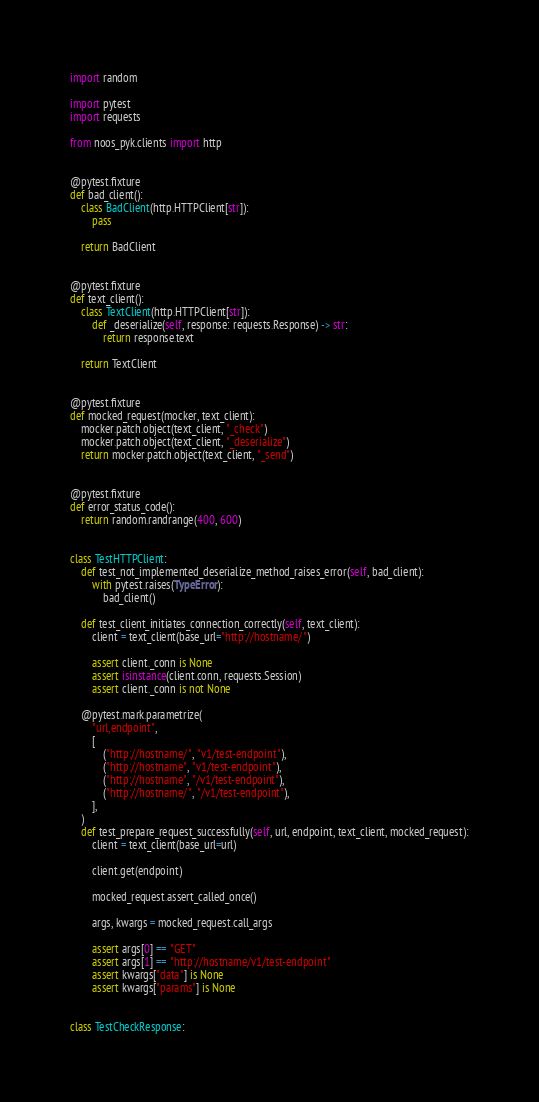Convert code to text. <code><loc_0><loc_0><loc_500><loc_500><_Python_>import random

import pytest
import requests

from noos_pyk.clients import http


@pytest.fixture
def bad_client():
    class BadClient(http.HTTPClient[str]):
        pass

    return BadClient


@pytest.fixture
def text_client():
    class TextClient(http.HTTPClient[str]):
        def _deserialize(self, response: requests.Response) -> str:
            return response.text

    return TextClient


@pytest.fixture
def mocked_request(mocker, text_client):
    mocker.patch.object(text_client, "_check")
    mocker.patch.object(text_client, "_deserialize")
    return mocker.patch.object(text_client, "_send")


@pytest.fixture
def error_status_code():
    return random.randrange(400, 600)


class TestHTTPClient:
    def test_not_implemented_deserialize_method_raises_error(self, bad_client):
        with pytest.raises(TypeError):
            bad_client()

    def test_client_initiates_connection_correctly(self, text_client):
        client = text_client(base_url="http://hostname/")

        assert client._conn is None
        assert isinstance(client.conn, requests.Session)
        assert client._conn is not None

    @pytest.mark.parametrize(
        "url,endpoint",
        [
            ("http://hostname/", "v1/test-endpoint"),
            ("http://hostname", "v1/test-endpoint"),
            ("http://hostname", "/v1/test-endpoint"),
            ("http://hostname/", "/v1/test-endpoint"),
        ],
    )
    def test_prepare_request_successfully(self, url, endpoint, text_client, mocked_request):
        client = text_client(base_url=url)

        client.get(endpoint)

        mocked_request.assert_called_once()

        args, kwargs = mocked_request.call_args

        assert args[0] == "GET"
        assert args[1] == "http://hostname/v1/test-endpoint"
        assert kwargs["data"] is None
        assert kwargs["params"] is None


class TestCheckResponse:</code> 